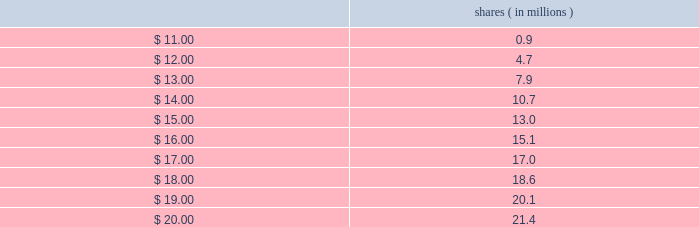All highly liquid securities with a maturity of three months or less at the date of purchase are considered to be cash equivalents .
Securities with maturities greater than three months are classified as available-for-sale and are considered to be short-term investments .
The carrying value of our interest-bearing instruments approximated fair value as of december 29 , 2012 .
Interest rates under our revolving credit facility are variable , so interest expense for periods when the credit facility is utilized could be adversely affected by changes in interest rates .
Interest rates under our revolving credit facility can fluctuate based on changes in market interest rates and in an interest rate margin that varies based on our consolidated leverage ratio .
As of december 29 , 2012 , we had no outstanding balance on the credit facility .
See note 3 in the notes to consolidated financial statements for an additional description of our credit facility .
Equity price risk convertible notes our 2015 notes and 2013 notes include conversion and settlement provisions that are based on the price of our common stock at conversion or at maturity of the notes .
In addition , the hedges and warrants associated with these convertible notes also include settlement provisions that are based on the price of our common stock .
The amount of cash we may be required to pay , or the number of shares we may be required to provide to note holders at conversion or maturity of these notes , is determined by the price of our common stock .
The amount of cash or number of shares that we may receive from hedge counterparties in connection with the related hedges and the number of shares that we may be required to provide warrant counterparties in connection with the related warrants are also determined by the price of our common stock .
Upon the expiration of our 2015 warrants , cadence will issue shares of common stock to the purchasers of the warrants to the extent our stock price exceeds the warrant strike price of $ 10.78 at that time .
The table shows the number of shares that cadence would issue to 2015 warrant counterparties at expiration of the warrants , assuming various cadence closing stock prices on the dates of warrant expiration : shares ( in millions ) .
Prior to the expiration of the 2015 warrants , for purposes of calculating diluted earnings per share , our diluted weighted-average shares outstanding will increase when our average closing stock price for a quarter exceeds $ 10.78 .
For an additional description of our 2015 notes and 2013 notes , see note 3 in the notes to consolidated financial statements and 201cliquidity and capital resources 2014 other factors affecting liquidity and capital resources , 201d under item 7 , 201cmanagement 2019s discussion and analysis of financial condition and results of operations . 201d .
What is the percentage difference in the number of shares to be issued if the stock price closes at $ 16 compared to if it closes at $ 20? 
Computations: ((21.4 - 15.1) / 15.1)
Answer: 0.41722. 